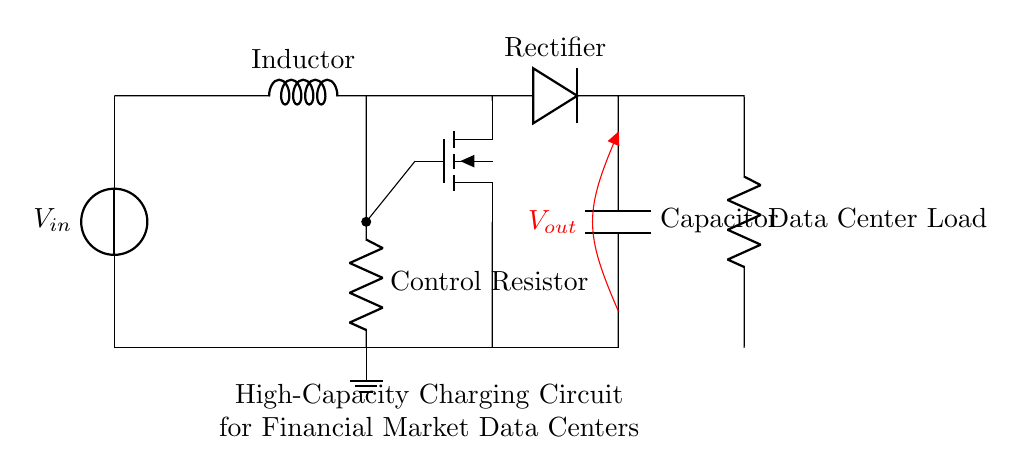What is the type of load in this circuit? The load is a Data Center Load, indicated by the component labeled as such in the circuit diagram.
Answer: Data Center Load What is the function of the rectifier in this circuit? The rectifier converts alternating current to direct current, allowing the circuit to provide the necessary voltage to the load.
Answer: Convert AC to DC How many energy storage components are present? There are two energy storage components: one inductor and one capacitor, which are responsible for storing energy in their respective forms.
Answer: Two What role does the control resistor play? The control resistor helps to adjust the current flowing to the MOSFET, which regulates the charging of the capacitor and helps manage the circuit's performance.
Answer: Adjusts current What is the output voltage measurement point labeled as? The voltage measurement point is labeled as Vout, indicating where the output voltage can be measured in relation to ground in the circuit.
Answer: Vout What will happen if the MOSFET fails? If the MOSFET fails, it can disrupt control over the current flowing from the inductor to the load, potentially leading to inadequate charging or overloading of the capacitor.
Answer: Disrupt current control How does the inductor influence the charging process? The inductor stores energy in a magnetic field when current flows through it and releases it, smoothing out the current and preventing sudden changes that could damage the circuit.
Answer: Smooths current 